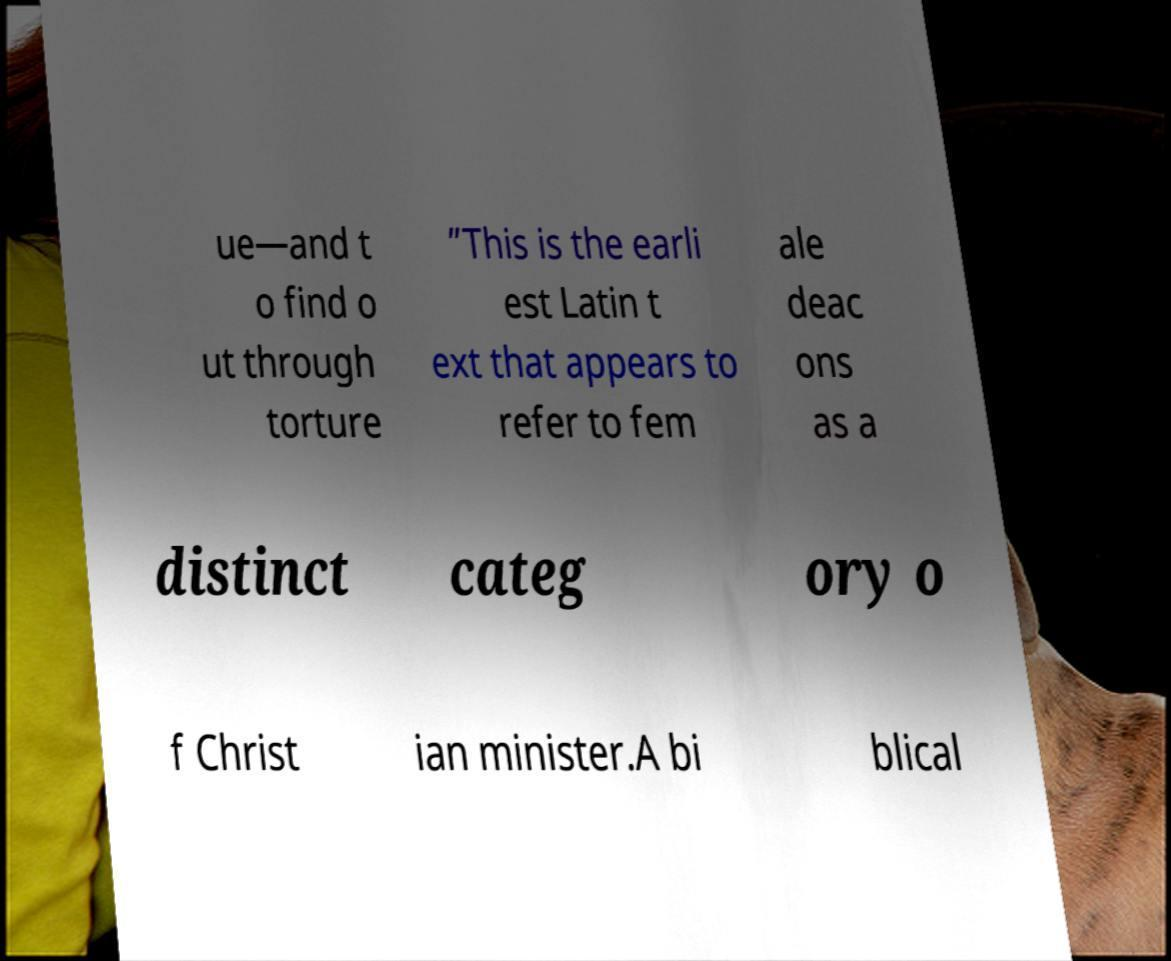There's text embedded in this image that I need extracted. Can you transcribe it verbatim? ue—and t o find o ut through torture ”This is the earli est Latin t ext that appears to refer to fem ale deac ons as a distinct categ ory o f Christ ian minister.A bi blical 